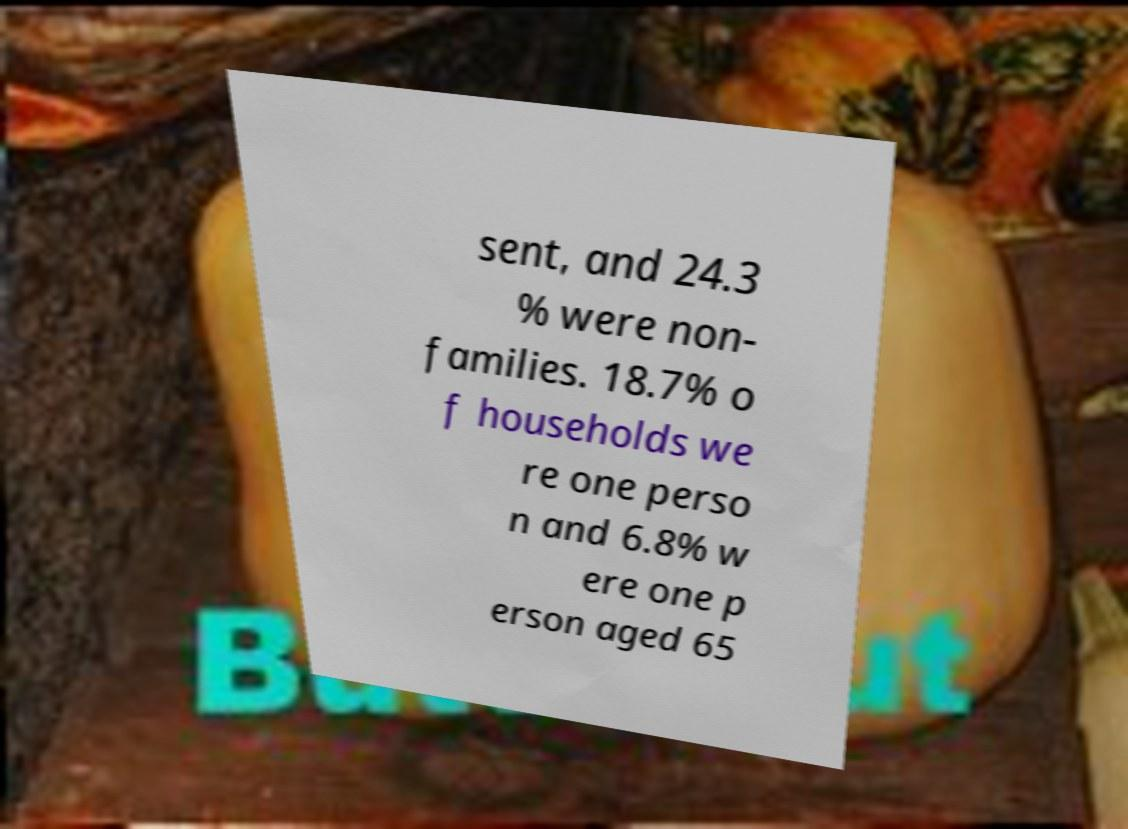Please read and relay the text visible in this image. What does it say? sent, and 24.3 % were non- families. 18.7% o f households we re one perso n and 6.8% w ere one p erson aged 65 